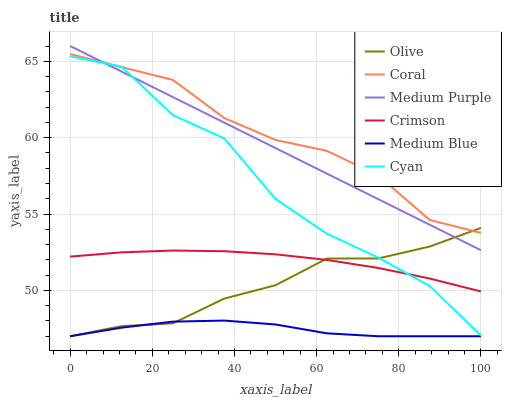Does Medium Blue have the minimum area under the curve?
Answer yes or no. Yes. Does Coral have the maximum area under the curve?
Answer yes or no. Yes. Does Medium Purple have the minimum area under the curve?
Answer yes or no. No. Does Medium Purple have the maximum area under the curve?
Answer yes or no. No. Is Medium Purple the smoothest?
Answer yes or no. Yes. Is Cyan the roughest?
Answer yes or no. Yes. Is Medium Blue the smoothest?
Answer yes or no. No. Is Medium Blue the roughest?
Answer yes or no. No. Does Medium Blue have the lowest value?
Answer yes or no. Yes. Does Medium Purple have the lowest value?
Answer yes or no. No. Does Medium Purple have the highest value?
Answer yes or no. Yes. Does Medium Blue have the highest value?
Answer yes or no. No. Is Medium Blue less than Coral?
Answer yes or no. Yes. Is Cyan greater than Medium Blue?
Answer yes or no. Yes. Does Medium Blue intersect Olive?
Answer yes or no. Yes. Is Medium Blue less than Olive?
Answer yes or no. No. Is Medium Blue greater than Olive?
Answer yes or no. No. Does Medium Blue intersect Coral?
Answer yes or no. No. 